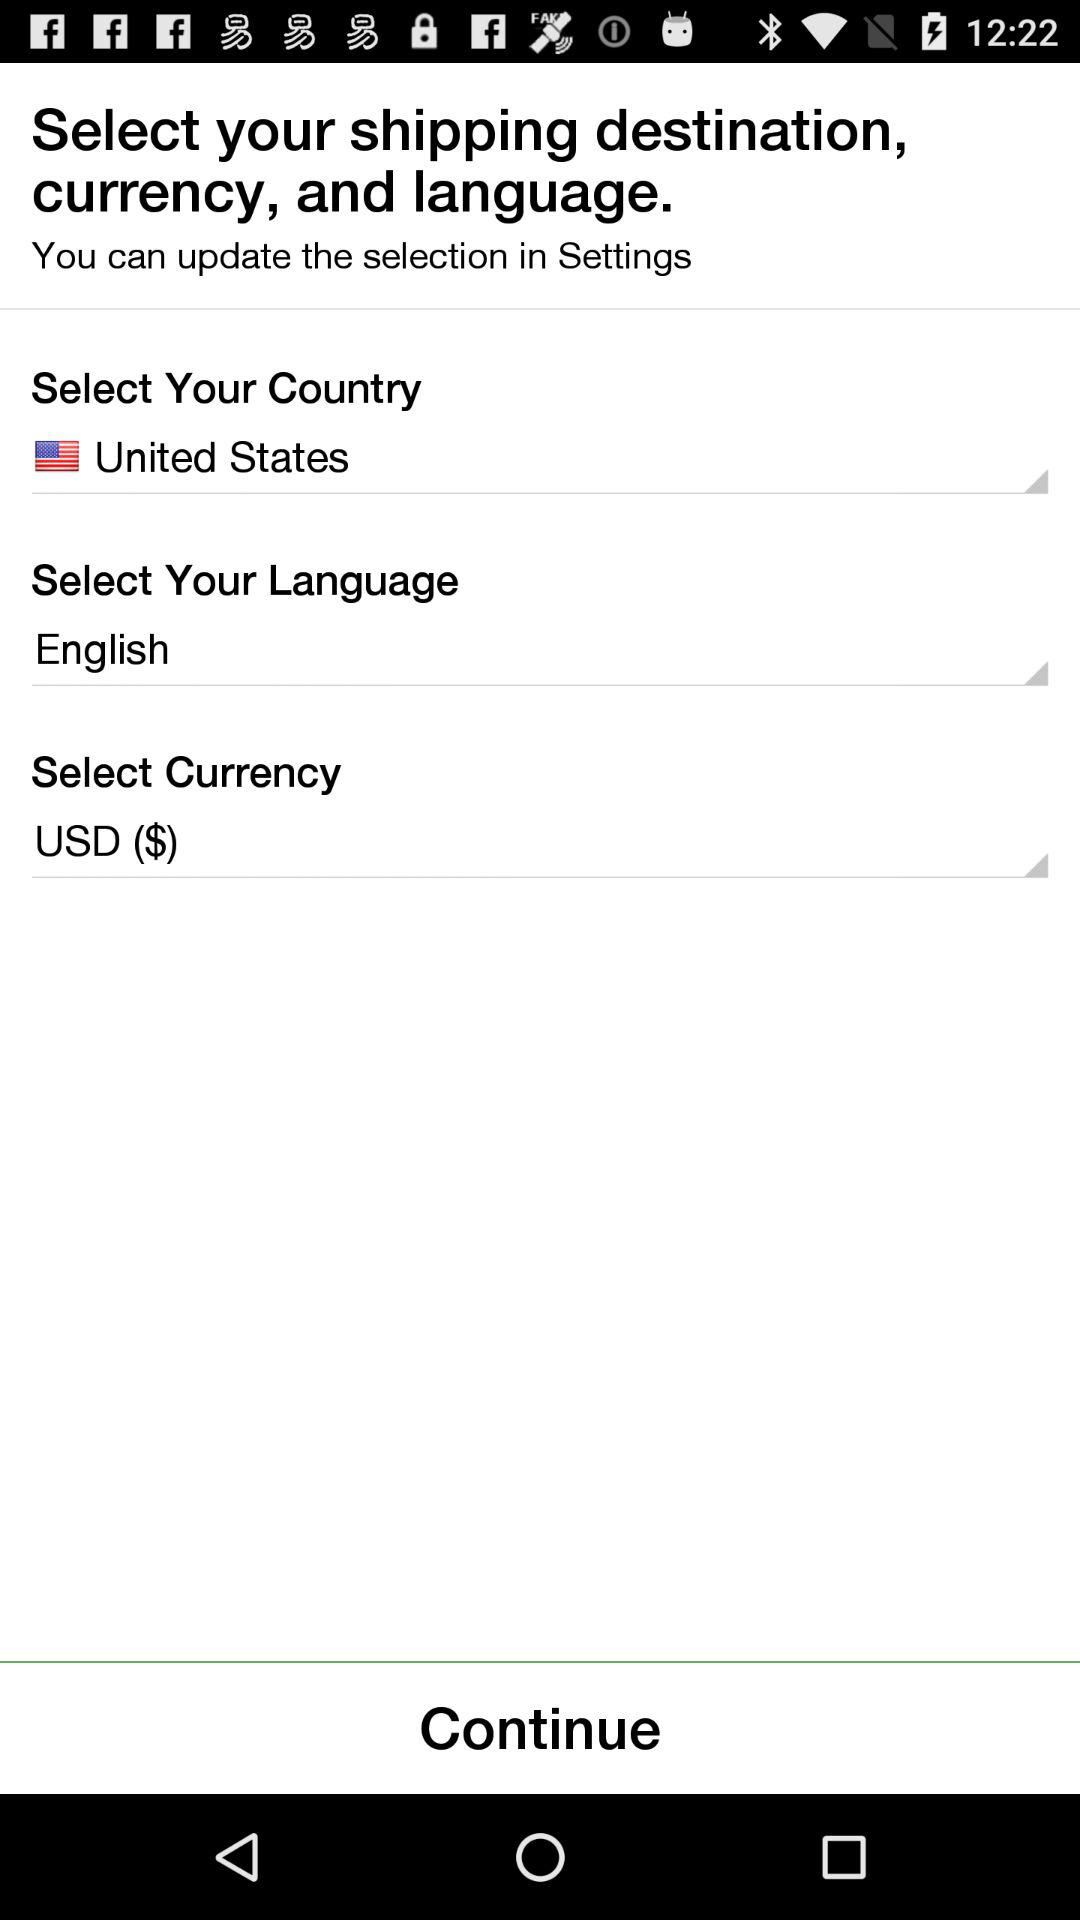What country is selected? The selected country is the United States. 